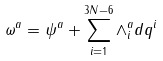Convert formula to latex. <formula><loc_0><loc_0><loc_500><loc_500>\omega ^ { a } = \psi ^ { a } + \sum _ { i = 1 } ^ { 3 N - 6 } \wedge ^ { a } _ { i } d q ^ { i }</formula> 